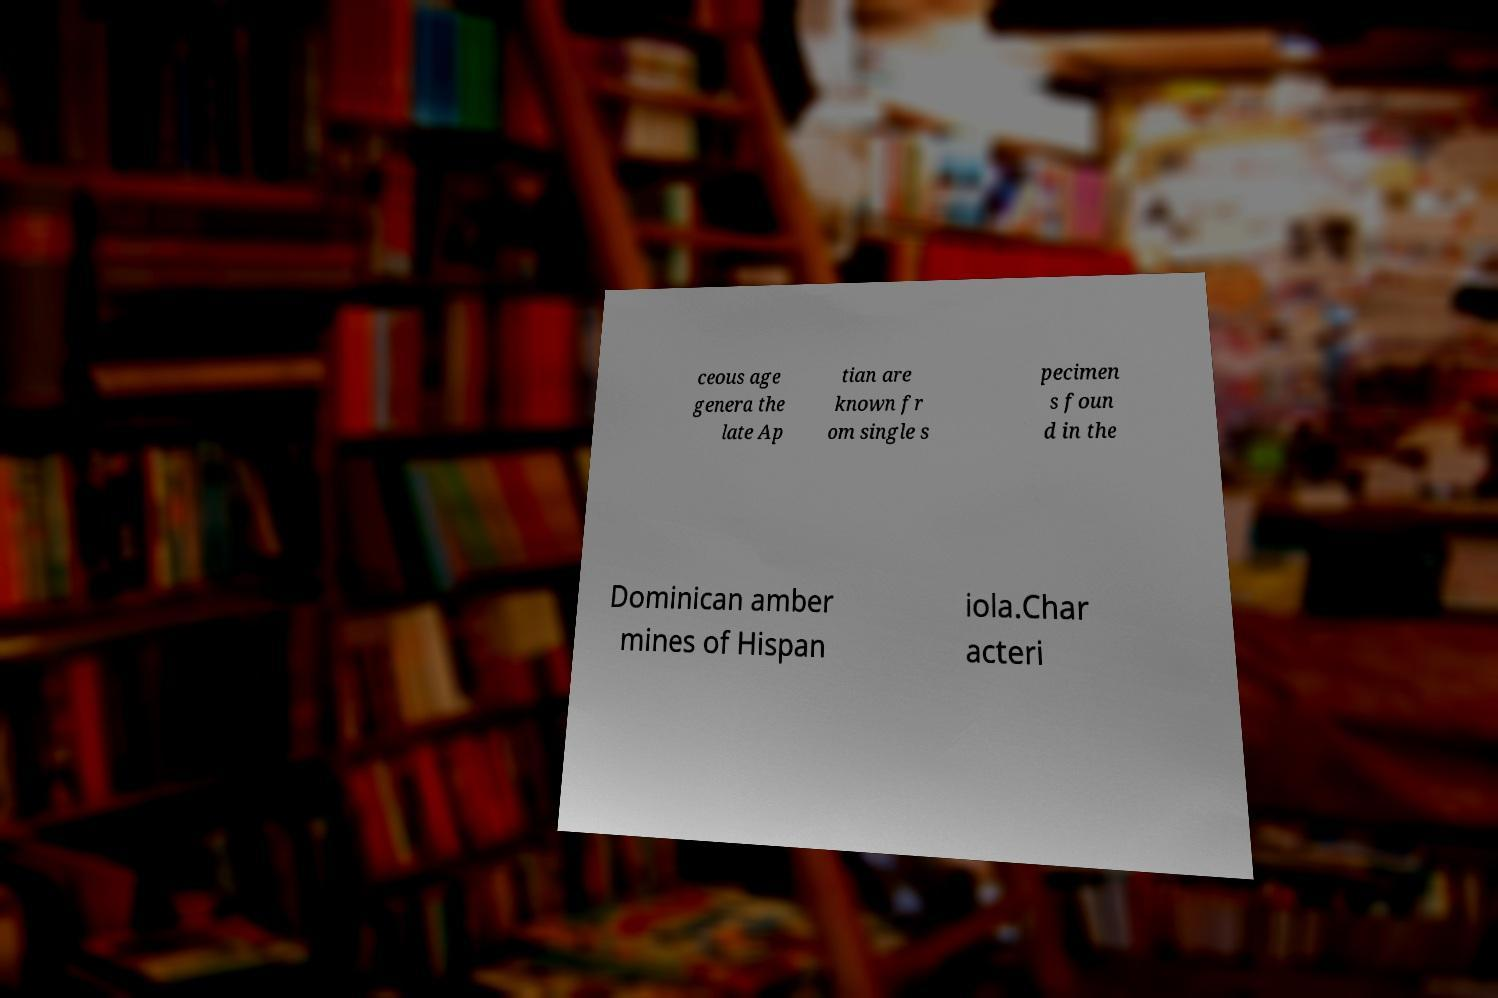There's text embedded in this image that I need extracted. Can you transcribe it verbatim? ceous age genera the late Ap tian are known fr om single s pecimen s foun d in the Dominican amber mines of Hispan iola.Char acteri 